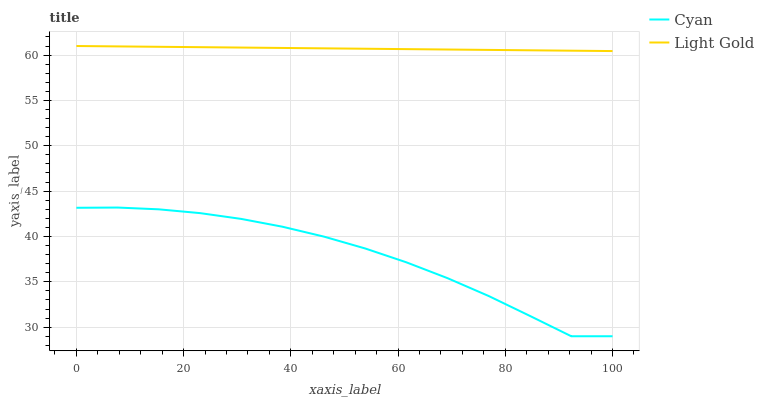Does Cyan have the minimum area under the curve?
Answer yes or no. Yes. Does Light Gold have the maximum area under the curve?
Answer yes or no. Yes. Does Light Gold have the minimum area under the curve?
Answer yes or no. No. Is Light Gold the smoothest?
Answer yes or no. Yes. Is Cyan the roughest?
Answer yes or no. Yes. Is Light Gold the roughest?
Answer yes or no. No. Does Cyan have the lowest value?
Answer yes or no. Yes. Does Light Gold have the lowest value?
Answer yes or no. No. Does Light Gold have the highest value?
Answer yes or no. Yes. Is Cyan less than Light Gold?
Answer yes or no. Yes. Is Light Gold greater than Cyan?
Answer yes or no. Yes. Does Cyan intersect Light Gold?
Answer yes or no. No. 